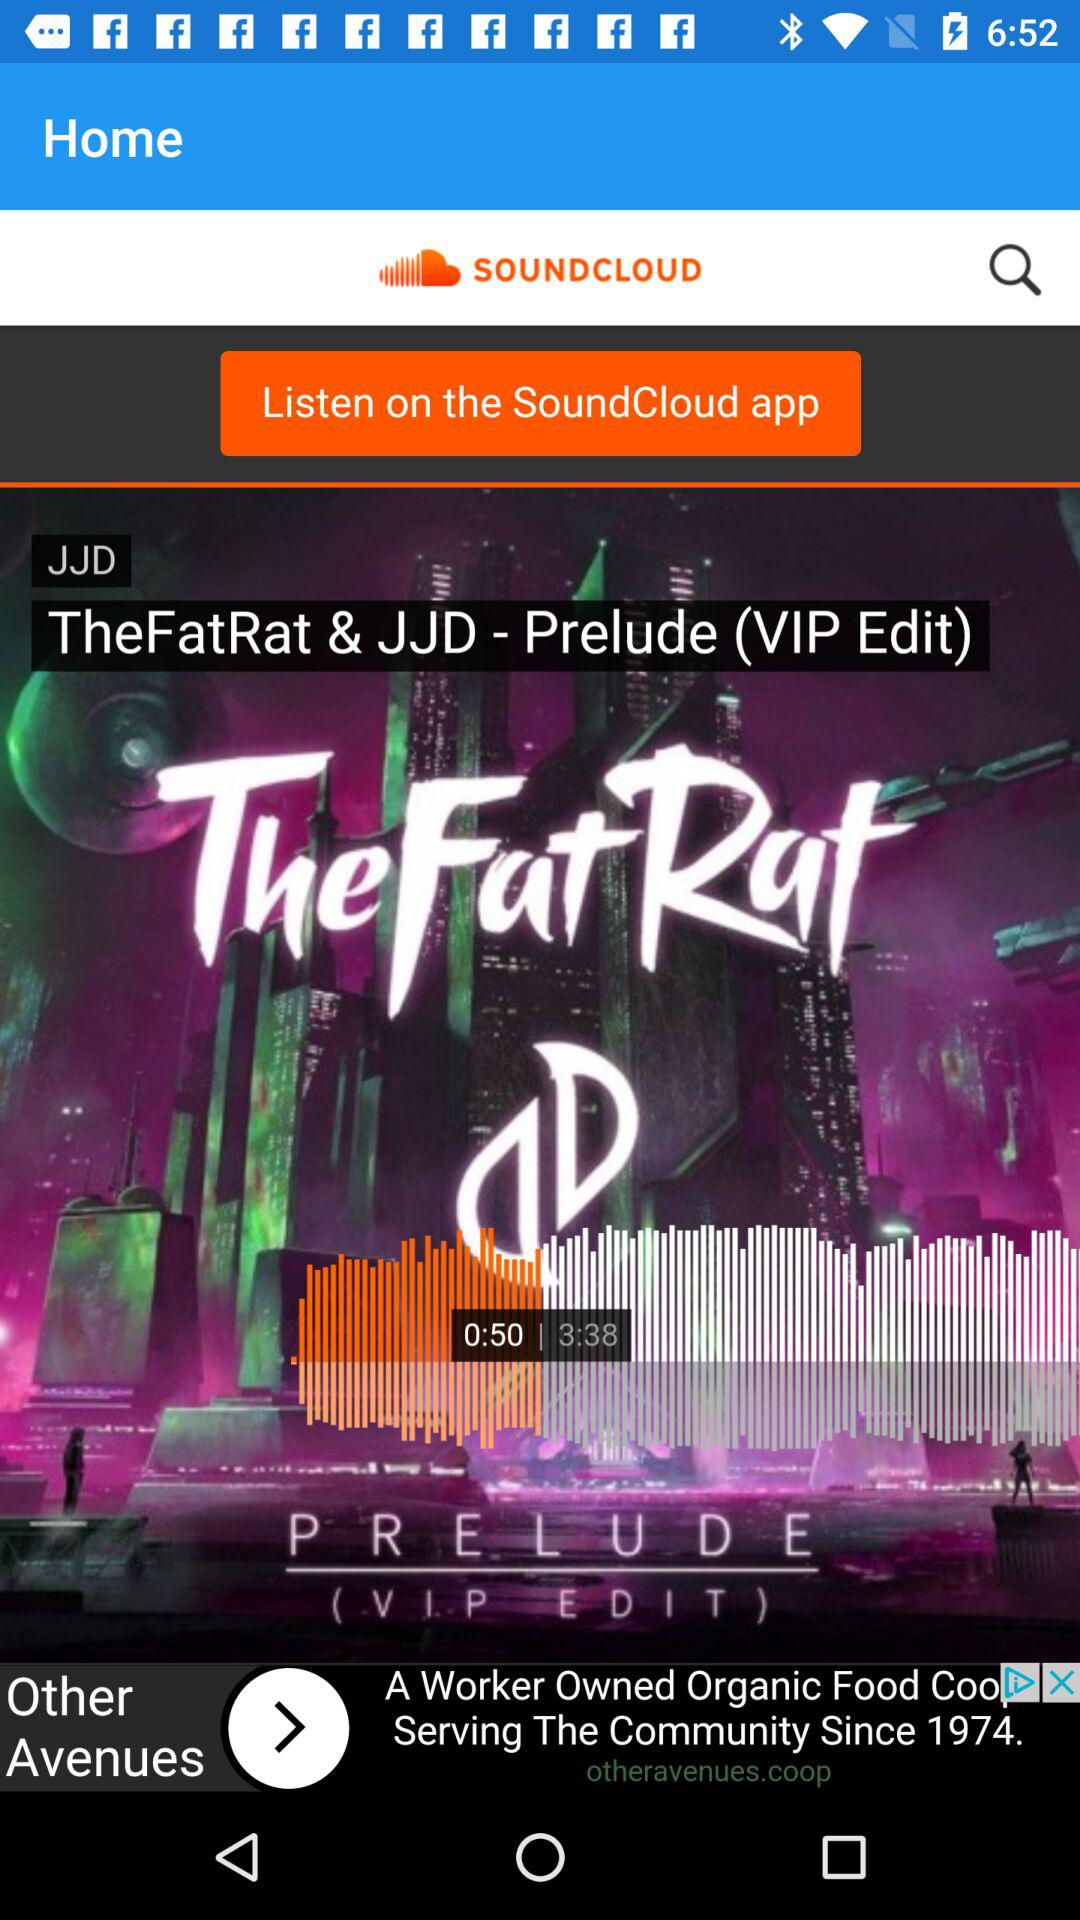What is the name of the application? The name of the application is "SOUNDCLOUD". 